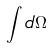<formula> <loc_0><loc_0><loc_500><loc_500>\int d \Omega</formula> 